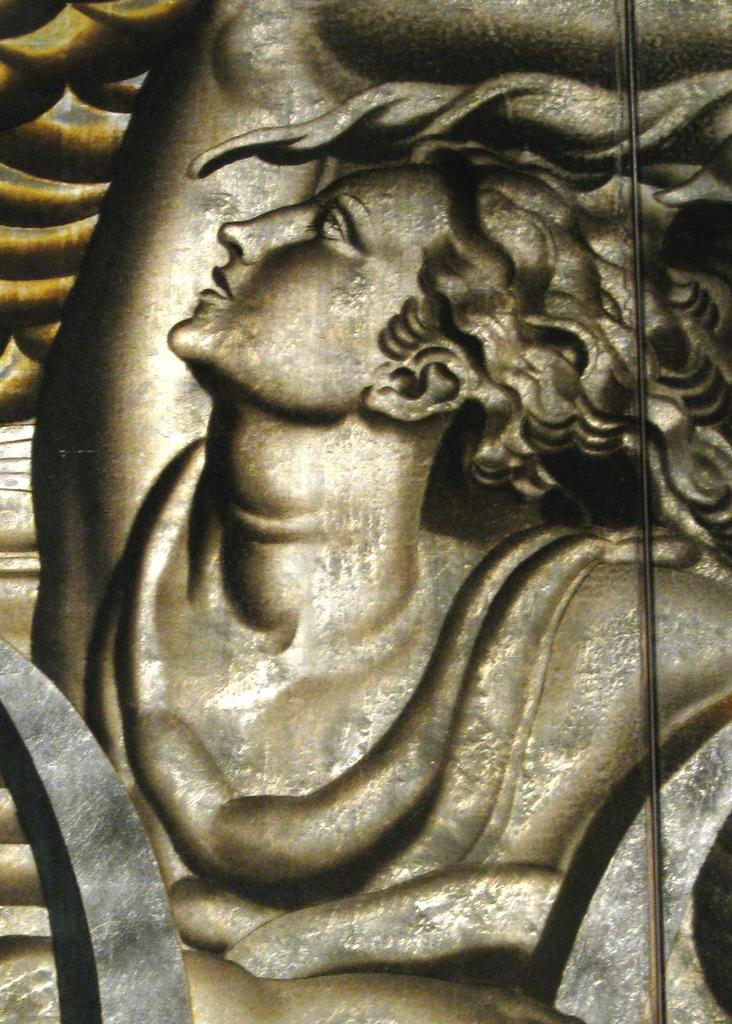What is the main subject of the image? There is a sculpture in the image. How many sponges are used to create the sculpture in the image? There is no information about sponges being used in the sculpture, as the fact only mentions that there is a sculpture in the image. 